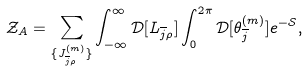<formula> <loc_0><loc_0><loc_500><loc_500>\mathcal { Z } _ { A } & = \sum _ { \{ J _ { \overline { j } \rho } ^ { ( m ) } \} } \int _ { - \infty } ^ { \infty } \mathcal { D } [ L _ { \overline { j } \rho } ] \int _ { 0 } ^ { 2 \pi } \mathcal { D } [ \theta _ { \overline { j } } ^ { ( m ) } ] e ^ { - \mathcal { S } } ,</formula> 